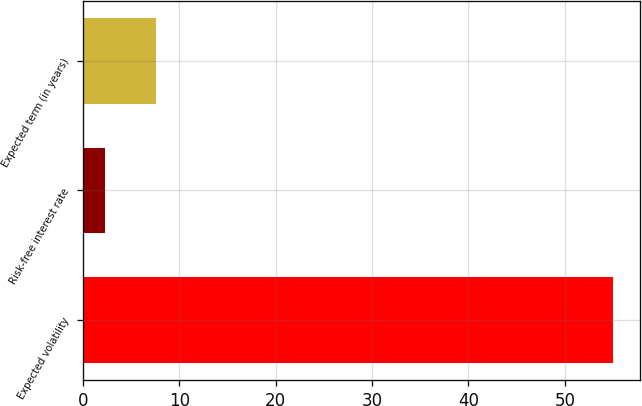Convert chart to OTSL. <chart><loc_0><loc_0><loc_500><loc_500><bar_chart><fcel>Expected volatility<fcel>Risk-free interest rate<fcel>Expected term (in years)<nl><fcel>55<fcel>2.3<fcel>7.57<nl></chart> 